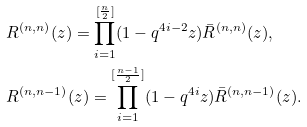Convert formula to latex. <formula><loc_0><loc_0><loc_500><loc_500>& R ^ { ( n , n ) } ( z ) = \prod _ { i = 1 } ^ { [ \frac { n } { 2 } ] } ( 1 - q ^ { 4 i - 2 } z ) \bar { R } ^ { ( n , n ) } ( z ) , \\ & R ^ { ( n , n - 1 ) } ( z ) = \prod _ { i = 1 } ^ { [ \frac { n - 1 } { 2 } ] } ( 1 - q ^ { 4 i } z ) \bar { R } ^ { ( n , n - 1 ) } ( z ) .</formula> 